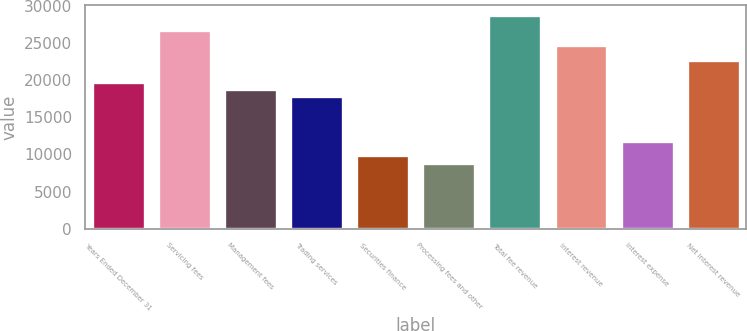<chart> <loc_0><loc_0><loc_500><loc_500><bar_chart><fcel>Years Ended December 31<fcel>Servicing fees<fcel>Management fees<fcel>Trading services<fcel>Securities finance<fcel>Processing fees and other<fcel>Total fee revenue<fcel>Interest revenue<fcel>Interest expense<fcel>Net interest revenue<nl><fcel>19767<fcel>26685.1<fcel>18778.7<fcel>17790.4<fcel>9884.04<fcel>8895.74<fcel>28661.7<fcel>24708.5<fcel>11860.6<fcel>22731.9<nl></chart> 